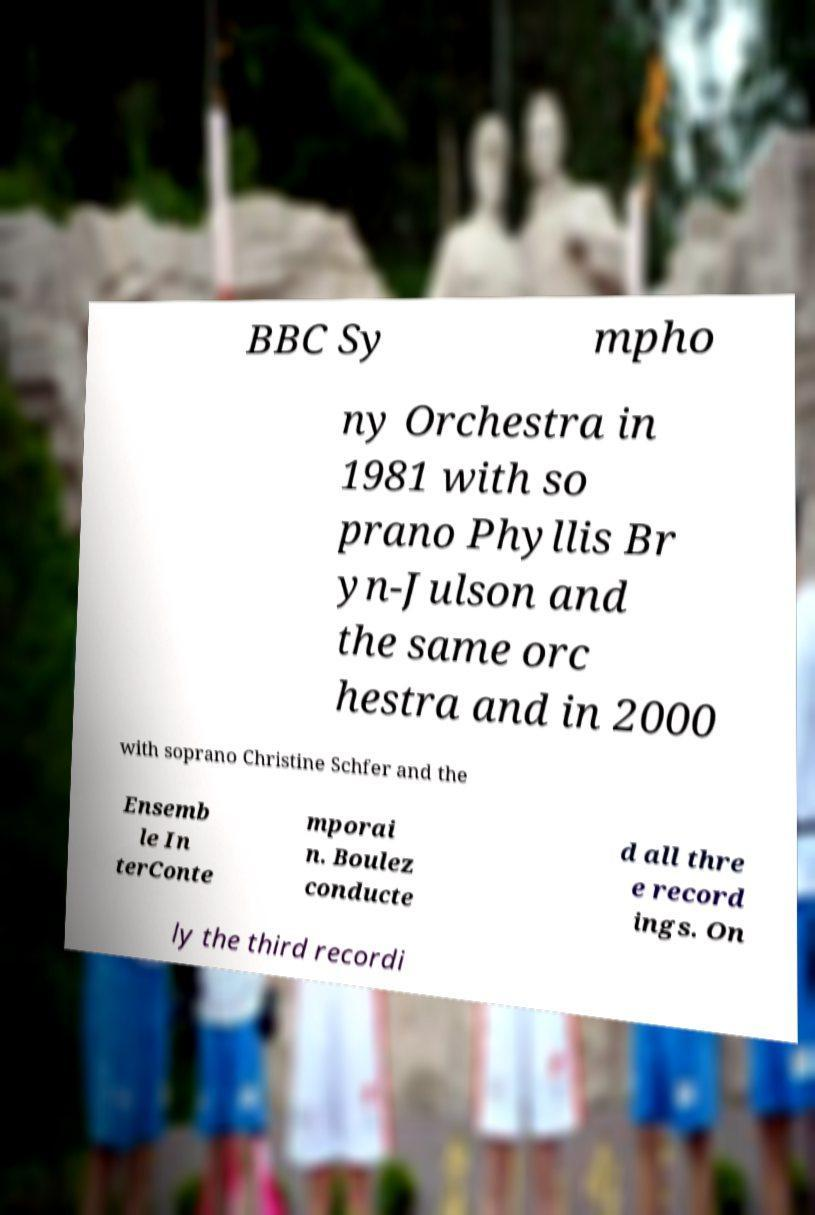What messages or text are displayed in this image? I need them in a readable, typed format. BBC Sy mpho ny Orchestra in 1981 with so prano Phyllis Br yn-Julson and the same orc hestra and in 2000 with soprano Christine Schfer and the Ensemb le In terConte mporai n. Boulez conducte d all thre e record ings. On ly the third recordi 